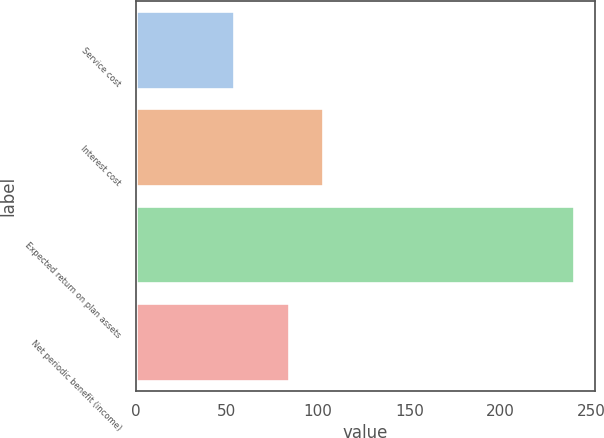Convert chart. <chart><loc_0><loc_0><loc_500><loc_500><bar_chart><fcel>Service cost<fcel>Interest cost<fcel>Expected return on plan assets<fcel>Net periodic benefit (income)<nl><fcel>54<fcel>102.6<fcel>240<fcel>84<nl></chart> 